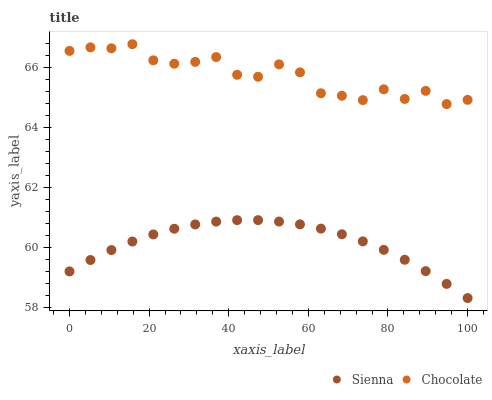Does Sienna have the minimum area under the curve?
Answer yes or no. Yes. Does Chocolate have the maximum area under the curve?
Answer yes or no. Yes. Does Chocolate have the minimum area under the curve?
Answer yes or no. No. Is Sienna the smoothest?
Answer yes or no. Yes. Is Chocolate the roughest?
Answer yes or no. Yes. Is Chocolate the smoothest?
Answer yes or no. No. Does Sienna have the lowest value?
Answer yes or no. Yes. Does Chocolate have the lowest value?
Answer yes or no. No. Does Chocolate have the highest value?
Answer yes or no. Yes. Is Sienna less than Chocolate?
Answer yes or no. Yes. Is Chocolate greater than Sienna?
Answer yes or no. Yes. Does Sienna intersect Chocolate?
Answer yes or no. No. 